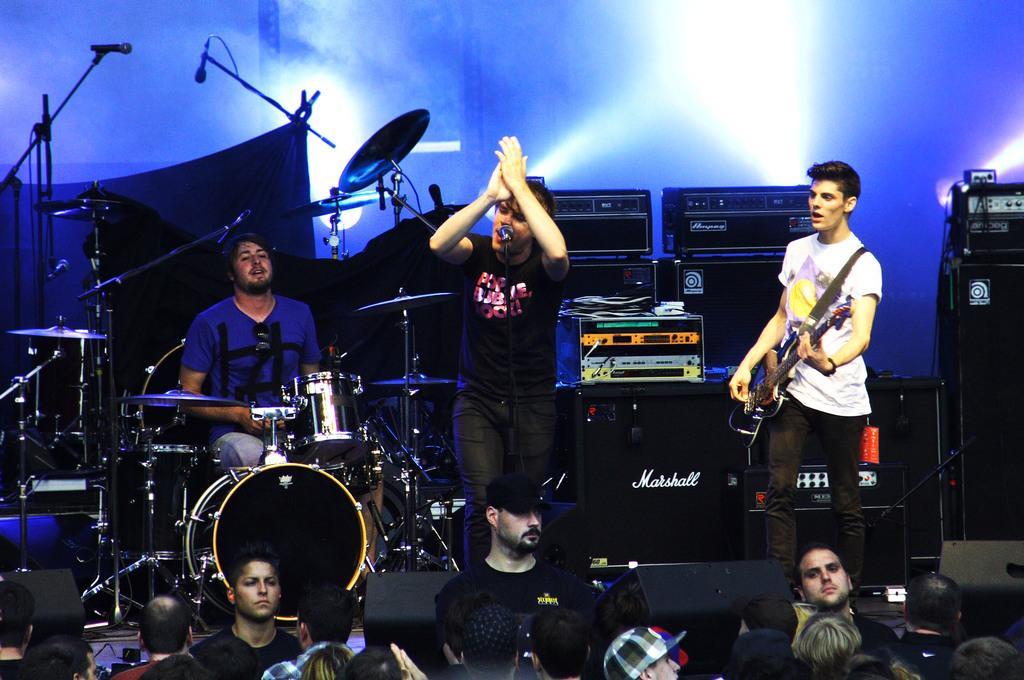Please provide a concise description of this image. In the image we can see there are many people wearing clothes and these are the musical instruments. This is a microphone, cable wire and a light. These are the sound boxes and there are audience. 